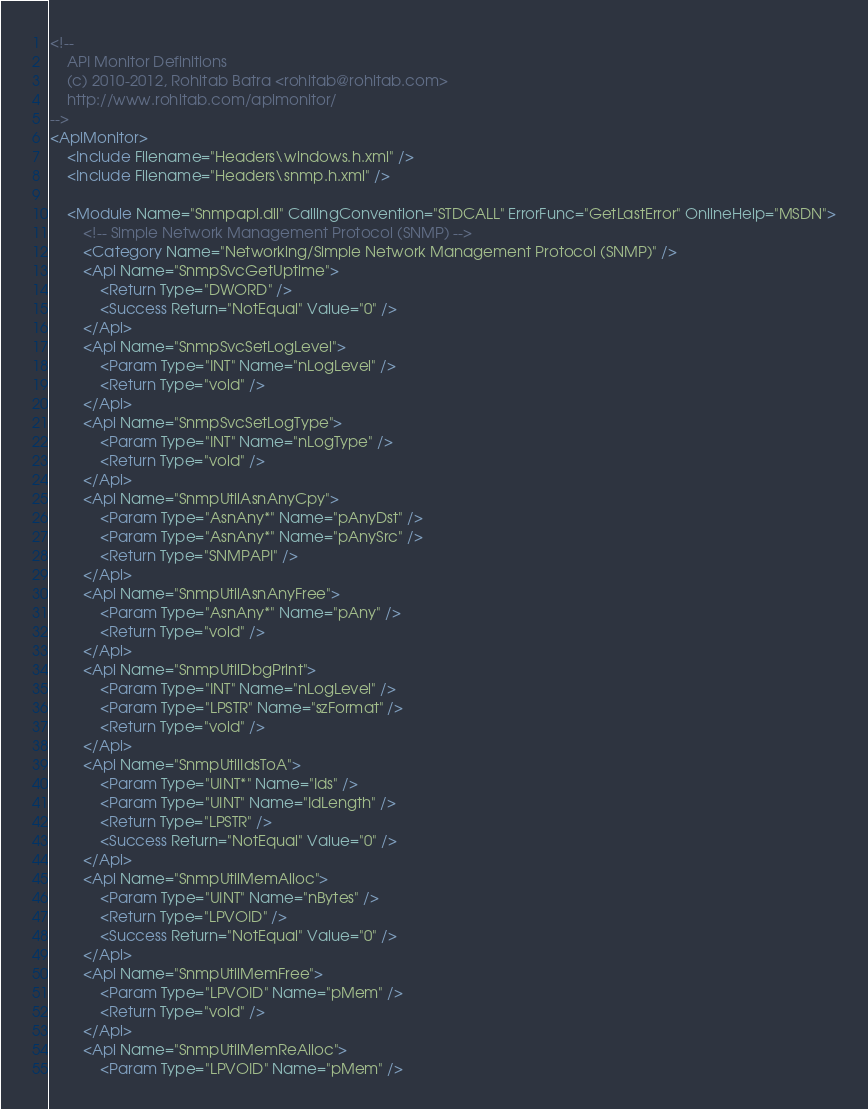<code> <loc_0><loc_0><loc_500><loc_500><_XML_><!--
    API Monitor Definitions
    (c) 2010-2012, Rohitab Batra <rohitab@rohitab.com>
    http://www.rohitab.com/apimonitor/
-->
<ApiMonitor>
    <Include Filename="Headers\windows.h.xml" />
    <Include Filename="Headers\snmp.h.xml" />
    
    <Module Name="Snmpapi.dll" CallingConvention="STDCALL" ErrorFunc="GetLastError" OnlineHelp="MSDN">
        <!-- Simple Network Management Protocol (SNMP) -->
        <Category Name="Networking/Simple Network Management Protocol (SNMP)" />
        <Api Name="SnmpSvcGetUptime">
            <Return Type="DWORD" />
            <Success Return="NotEqual" Value="0" />
        </Api>
        <Api Name="SnmpSvcSetLogLevel">
            <Param Type="INT" Name="nLogLevel" />
            <Return Type="void" />
        </Api>
        <Api Name="SnmpSvcSetLogType">
            <Param Type="INT" Name="nLogType" />
            <Return Type="void" />
        </Api>
        <Api Name="SnmpUtilAsnAnyCpy">
            <Param Type="AsnAny*" Name="pAnyDst" />
            <Param Type="AsnAny*" Name="pAnySrc" />
            <Return Type="SNMPAPI" />
        </Api>
        <Api Name="SnmpUtilAsnAnyFree">
            <Param Type="AsnAny*" Name="pAny" />
            <Return Type="void" />
        </Api>
        <Api Name="SnmpUtilDbgPrint">
            <Param Type="INT" Name="nLogLevel" />
            <Param Type="LPSTR" Name="szFormat" />
            <Return Type="void" />
        </Api>
        <Api Name="SnmpUtilIdsToA">
            <Param Type="UINT*" Name="Ids" />
            <Param Type="UINT" Name="IdLength" />
            <Return Type="LPSTR" />
            <Success Return="NotEqual" Value="0" />
        </Api>
        <Api Name="SnmpUtilMemAlloc">
            <Param Type="UINT" Name="nBytes" />
            <Return Type="LPVOID" />
            <Success Return="NotEqual" Value="0" />
        </Api>
        <Api Name="SnmpUtilMemFree">
            <Param Type="LPVOID" Name="pMem" />
            <Return Type="void" />
        </Api>
        <Api Name="SnmpUtilMemReAlloc">
            <Param Type="LPVOID" Name="pMem" /></code> 